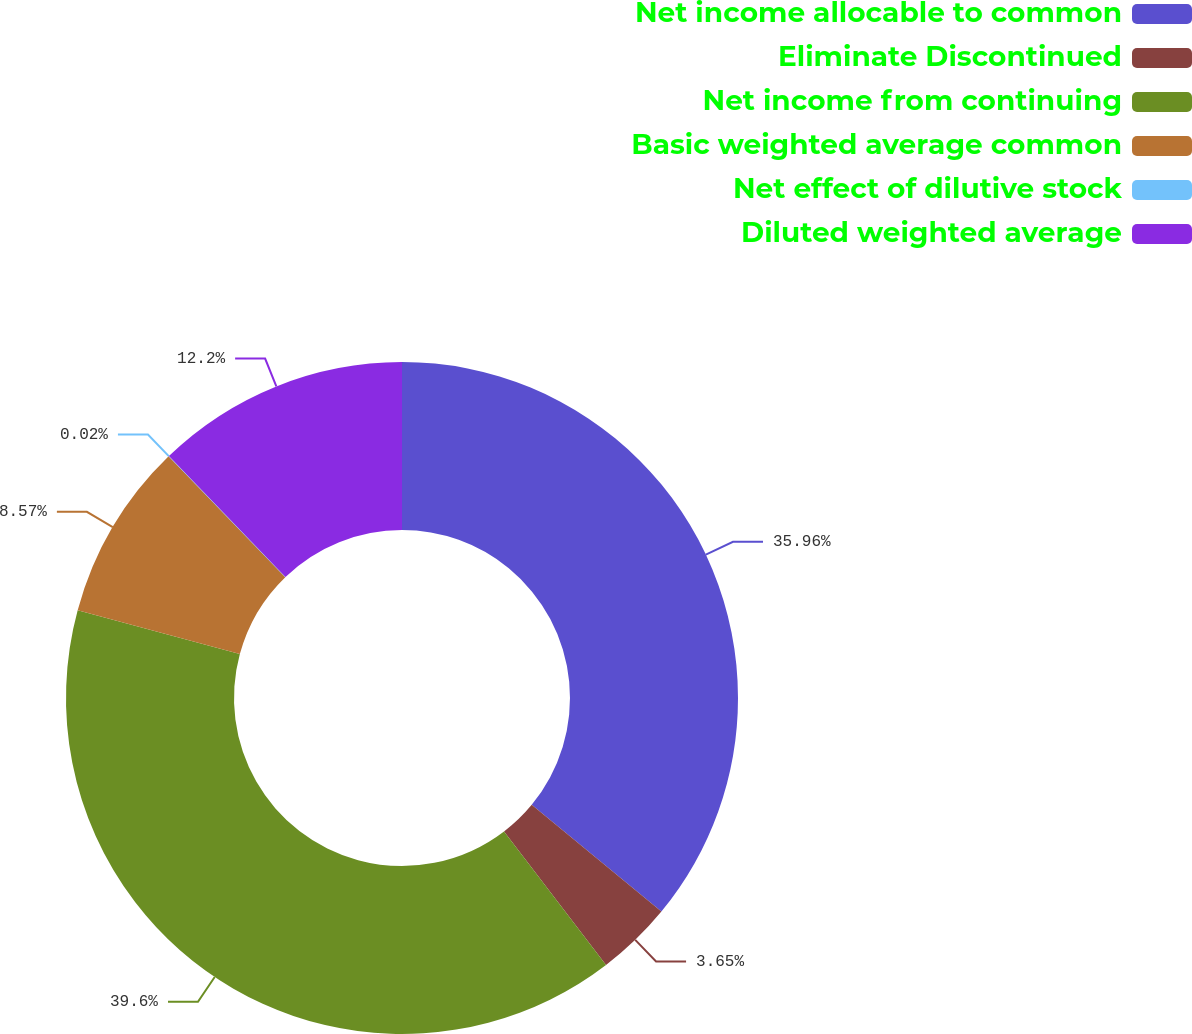Convert chart. <chart><loc_0><loc_0><loc_500><loc_500><pie_chart><fcel>Net income allocable to common<fcel>Eliminate Discontinued<fcel>Net income from continuing<fcel>Basic weighted average common<fcel>Net effect of dilutive stock<fcel>Diluted weighted average<nl><fcel>35.96%<fcel>3.65%<fcel>39.59%<fcel>8.57%<fcel>0.02%<fcel>12.2%<nl></chart> 